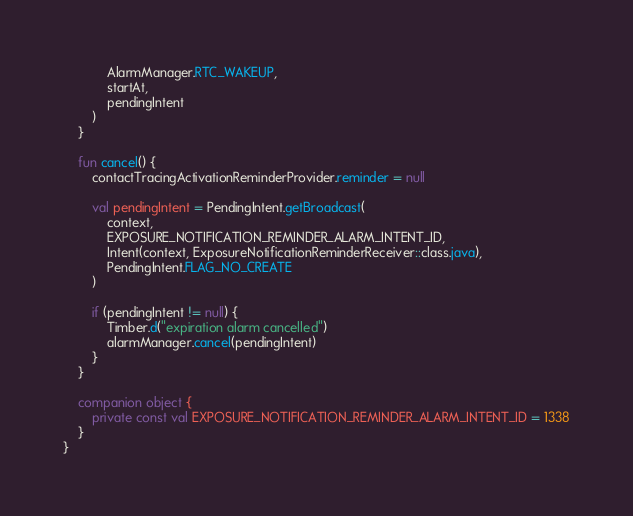Convert code to text. <code><loc_0><loc_0><loc_500><loc_500><_Kotlin_>            AlarmManager.RTC_WAKEUP,
            startAt,
            pendingIntent
        )
    }

    fun cancel() {
        contactTracingActivationReminderProvider.reminder = null

        val pendingIntent = PendingIntent.getBroadcast(
            context,
            EXPOSURE_NOTIFICATION_REMINDER_ALARM_INTENT_ID,
            Intent(context, ExposureNotificationReminderReceiver::class.java),
            PendingIntent.FLAG_NO_CREATE
        )

        if (pendingIntent != null) {
            Timber.d("expiration alarm cancelled")
            alarmManager.cancel(pendingIntent)
        }
    }

    companion object {
        private const val EXPOSURE_NOTIFICATION_REMINDER_ALARM_INTENT_ID = 1338
    }
}
</code> 